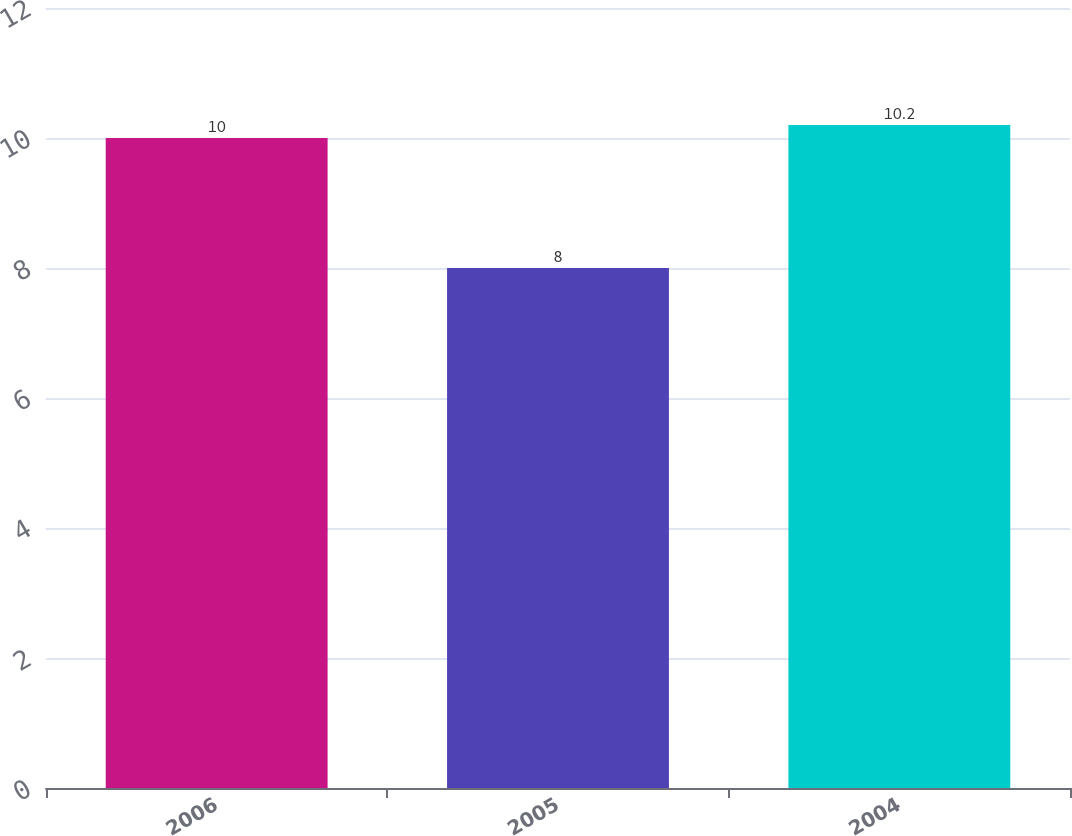<chart> <loc_0><loc_0><loc_500><loc_500><bar_chart><fcel>2006<fcel>2005<fcel>2004<nl><fcel>10<fcel>8<fcel>10.2<nl></chart> 